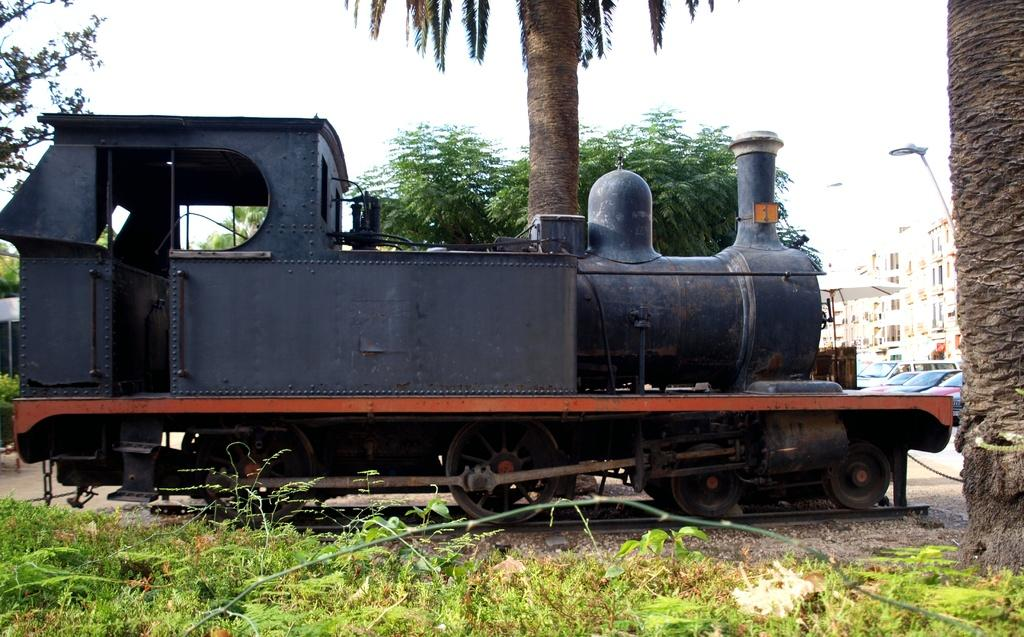What is the main subject of the image? There is a railway engine in the image. What can be seen in the background of the image? There are trees, buildings, and plants visible in the image. What type of transportation is present on the road in the image? Motor vehicles are visible on the road in the image. What additional features can be seen in the image? Creepers are present in the image, and the ground is visible. What type of ant can be seen singing in the image? There are no ants present in the image, and therefore no such activity can be observed. What is the voice of the plant in the image? Plants do not have voices, so this question cannot be answered. 